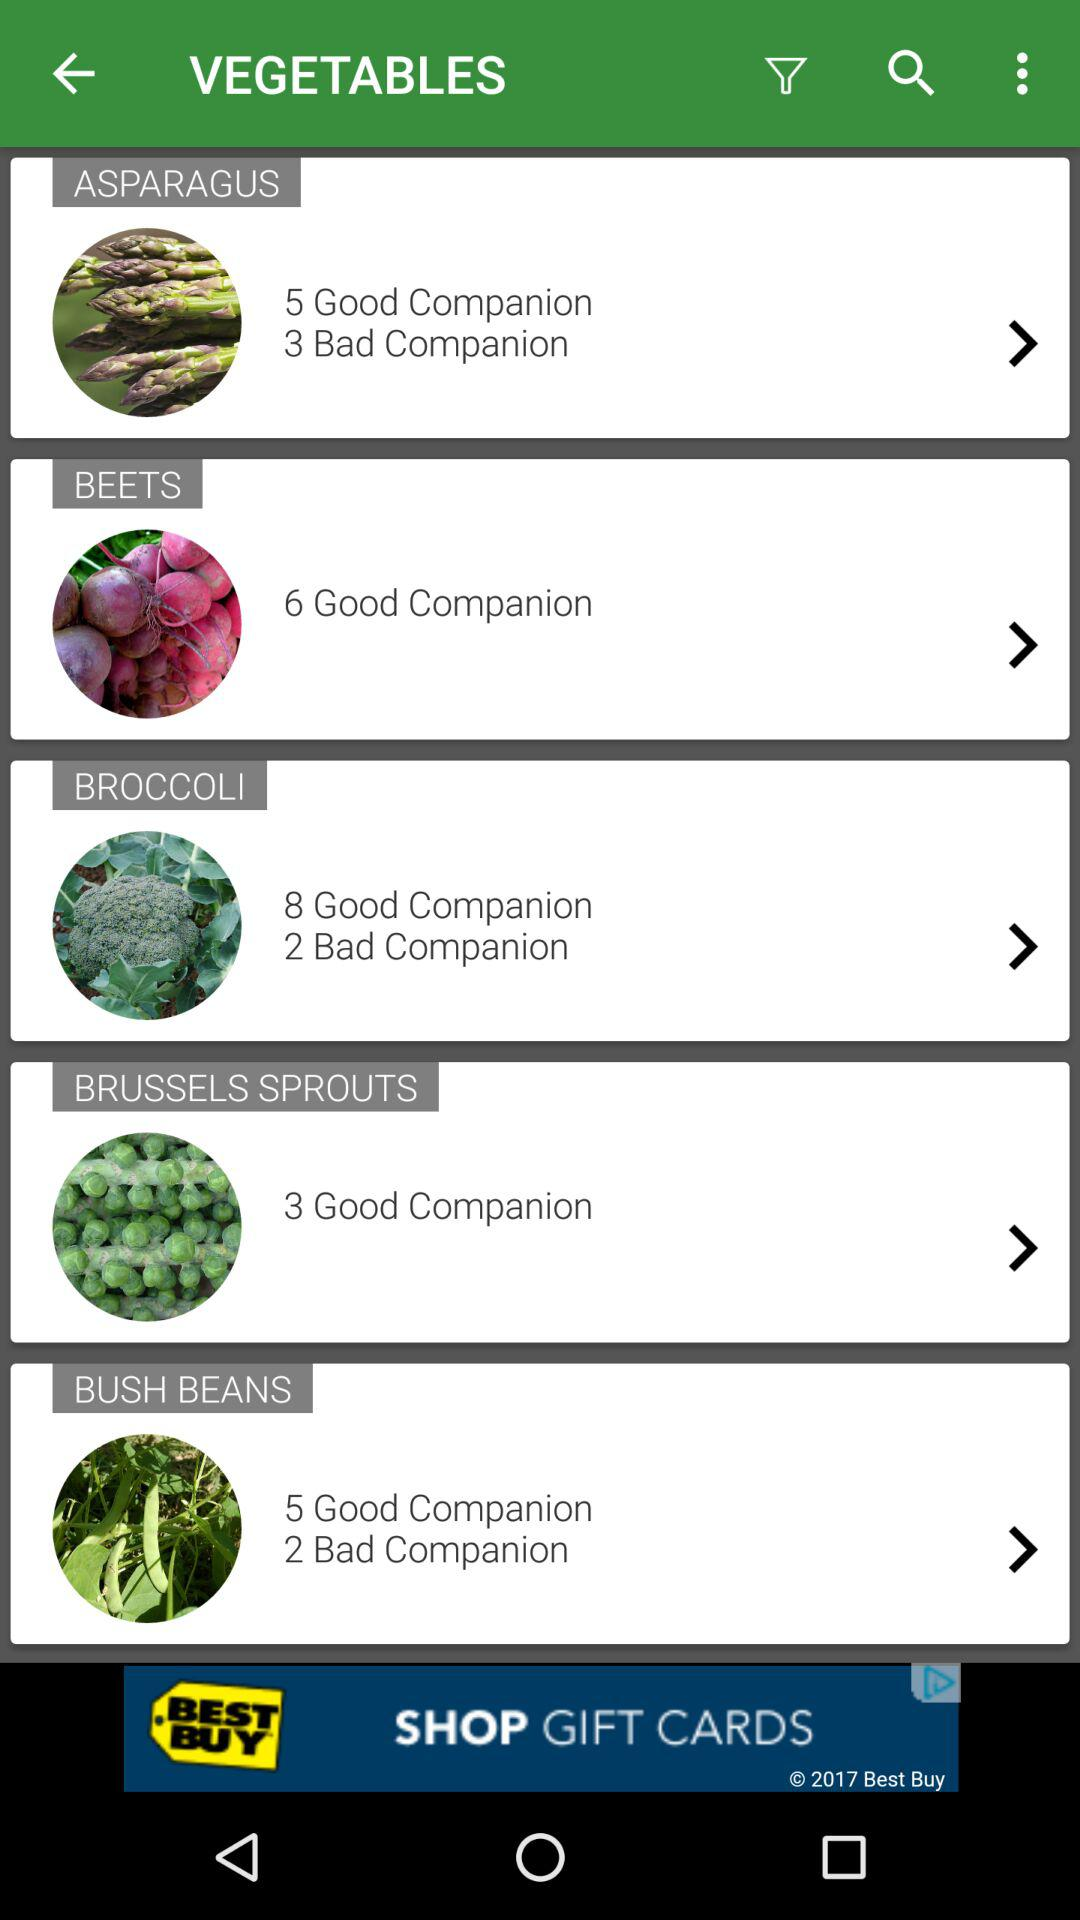What are the names of the vegetables? The names of the vegetables are "ASPARAGUS", "BEETS", "BROCCOLI", "BRUSSELS SPROUTS" and "BUSH BEANS". 